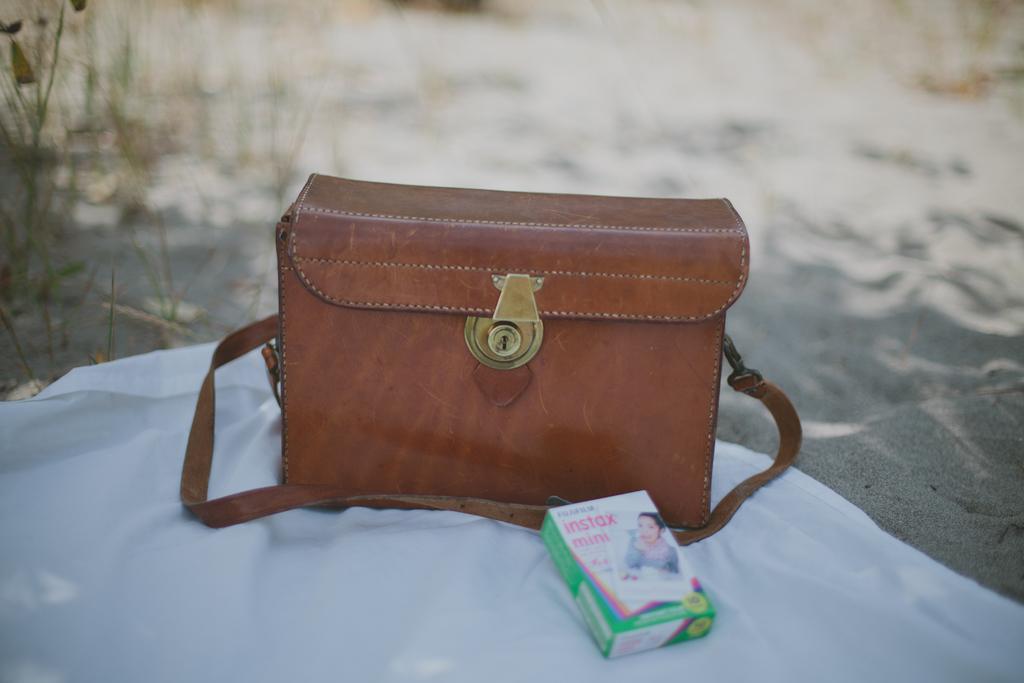Can you describe this image briefly? In this picture we can see bag with lock to it and in front of this there is mint box and this two are placed on a white color cloth on floor and in background we can see trees. 